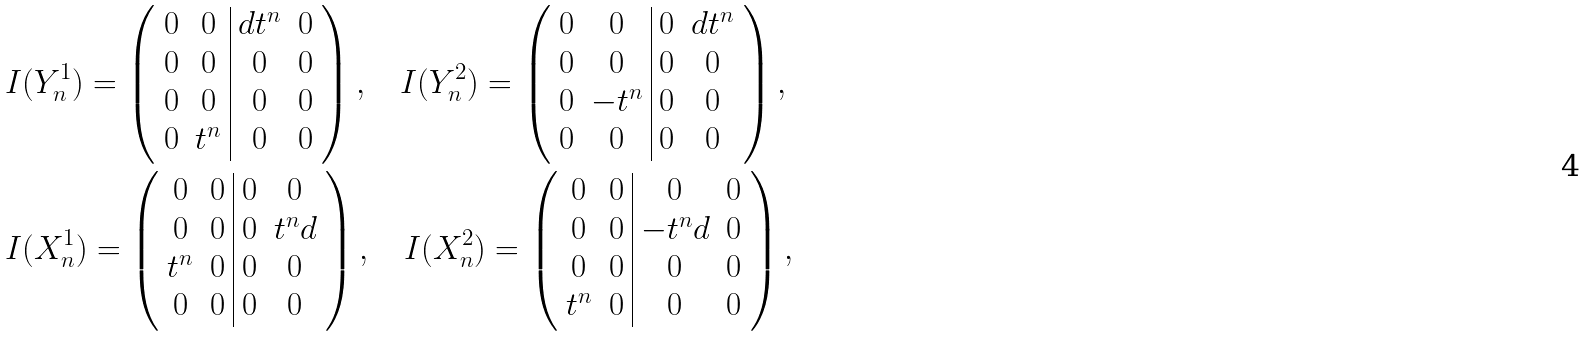Convert formula to latex. <formula><loc_0><loc_0><loc_500><loc_500>& I ( Y _ { n } ^ { 1 } ) = \left ( \begin{array} { c c | c c } 0 & 0 & d t ^ { n } & 0 \\ 0 & 0 & 0 & 0 \\ 0 & 0 & 0 & 0 \\ 0 & t ^ { n } & 0 & 0 \end{array} \right ) , \quad I ( Y _ { n } ^ { 2 } ) = \left ( \begin{array} { c c | c c } 0 & 0 & 0 & d t ^ { n } \\ 0 & 0 & 0 & 0 \\ 0 & - t ^ { n } & 0 & 0 \\ 0 & 0 & 0 & 0 \end{array} \right ) , \\ & I ( X _ { n } ^ { 1 } ) = \left ( \begin{array} { c c | c c } 0 & 0 & 0 & 0 \\ 0 & 0 & 0 & t ^ { n } d \\ t ^ { n } & 0 & 0 & 0 \\ 0 & 0 & 0 & 0 \end{array} \right ) , \quad I ( X _ { n } ^ { 2 } ) = \left ( \begin{array} { c c | c c } 0 & 0 & 0 & 0 \\ 0 & 0 & - t ^ { n } d & 0 \\ 0 & 0 & 0 & 0 \\ t ^ { n } & 0 & 0 & 0 \end{array} \right ) ,</formula> 